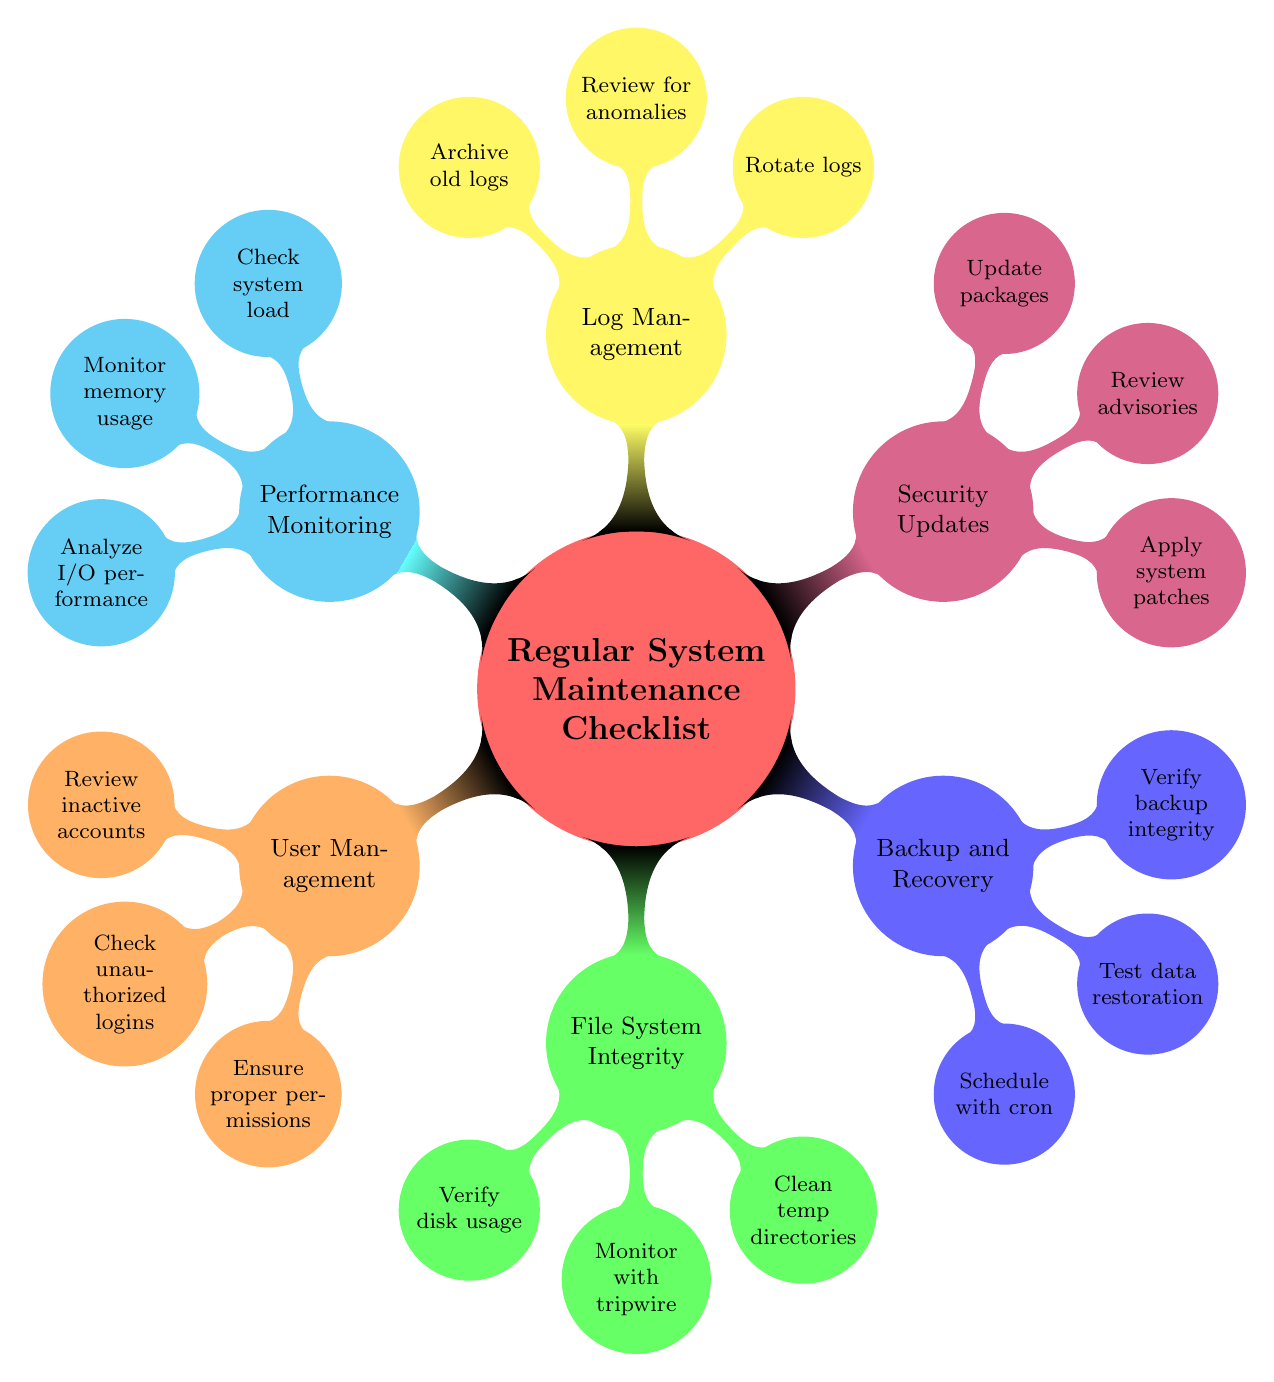What is the main topic of the mind map? The main topic, which is the central node in the diagram, is labeled "Regular System Maintenance Checklist." This is evident as it's the first node that branches out into different categories.
Answer: Regular System Maintenance Checklist How many main categories are there? Counting the child nodes directly connected to the central node, there are six main categories: User Management, File System Integrity, Backup and Recovery, Security Updates, Log Management, and Performance Monitoring.
Answer: Six Which category includes "Schedule regular backups with cron"? This element is listed under the "Backup and Recovery" category, which is directly derived from the main topic, indicating its relevance to the backups and data recovery processes.
Answer: Backup and Recovery What are the elements listed under "Log Management"? The three elements listed under "Log Management" include rotating logs, reviewing log files for anomalies, and archiving old logs. This insight can be gathered from the child nodes of the Log Management category.
Answer: Rotate logs, Review for anomalies, Archive old logs How many elements are in the "User Management" category? There are three specific elements outlined in the "User Management" category: reviewing inactive accounts, checking for unauthorized logins, and ensuring proper user permissions. Each of these is a child node of the User Management category.
Answer: Three Which two categories relate to security? The two categories that relate to security are "User Management" (which includes checking for unauthorized logins) and "Security Updates" (which involves applying system patches and reviewing advisories). Together, they depict a comprehensive approach to maintaining system security.
Answer: User Management, Security Updates What is the last element in the "Performance Monitoring" category? The last element in this category is "Analyze I/O performance with iostat." This element is the final child node under the Performance Monitoring category, indicating its specific focus within the overall performance checks.
Answer: Analyze I/O performance with iostat Which command-line tools are mentioned in the diagram? The mind map mentions commands such as `top`, `htop`, and `iostat` pertaining to performance monitoring, and `apt` or `yum` for applying system patches under security updates. These tools provide efficient command-line operations for system administration tasks.
Answer: top, htop, iostat, apt, yum What is the relationship between Backup and Recovery and Performance Monitoring? Both categories are distinct nodes under the mind map's main topic, but they collectively contribute to system maintenance—Backup and Recovery focuses on data safety, while Performance Monitoring ensures the system's operation is running smoothly. Their relationship depicts a holistic approach to system health.
Answer: Distinct but complementary 